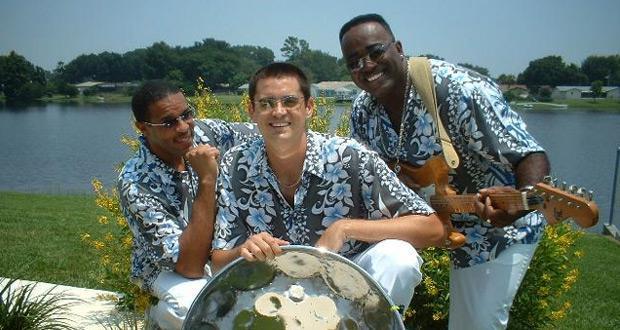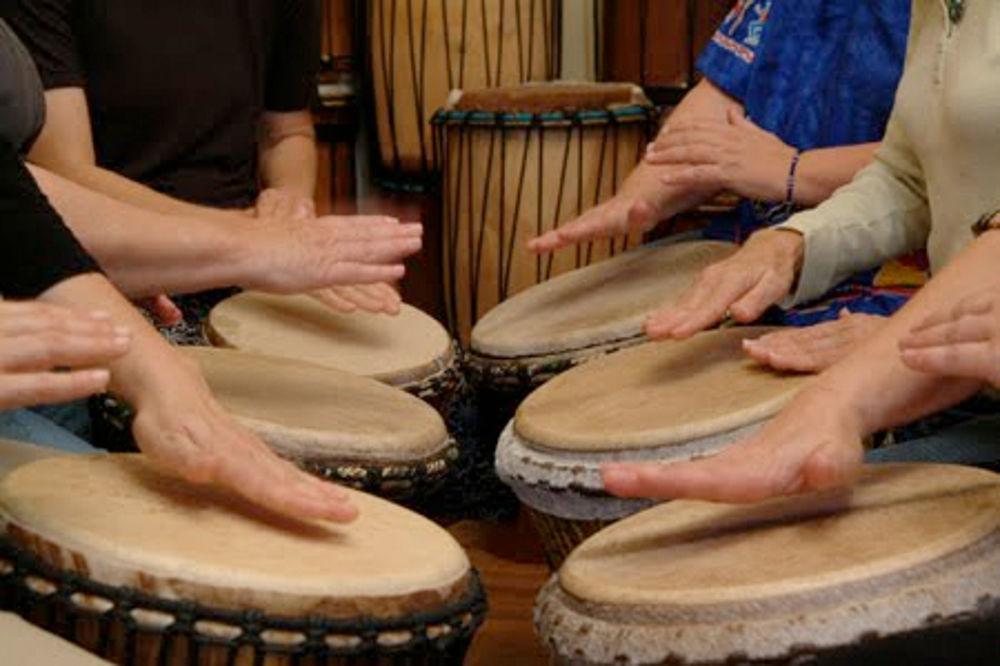The first image is the image on the left, the second image is the image on the right. For the images displayed, is the sentence "People are playing bongo drums." factually correct? Answer yes or no. Yes. 